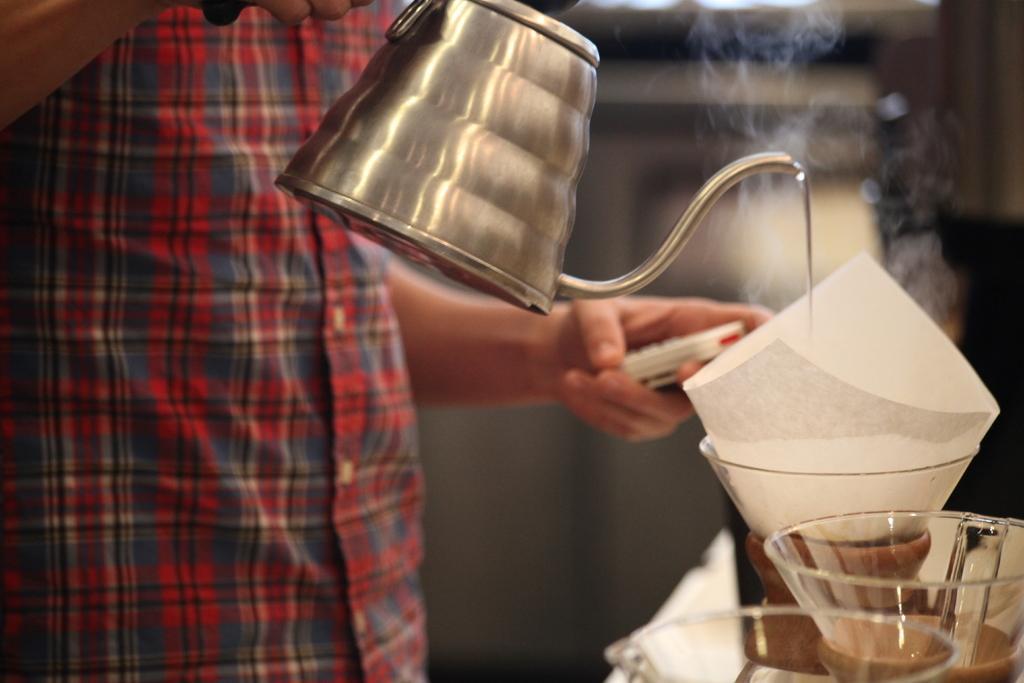In one or two sentences, can you explain what this image depicts? In this picture we can see a person is holding a kettle, on the right side we can see glasses and a paper, there is a blurry background. 